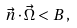<formula> <loc_0><loc_0><loc_500><loc_500>\vec { n } \cdot \vec { \Omega } < B \, ,</formula> 